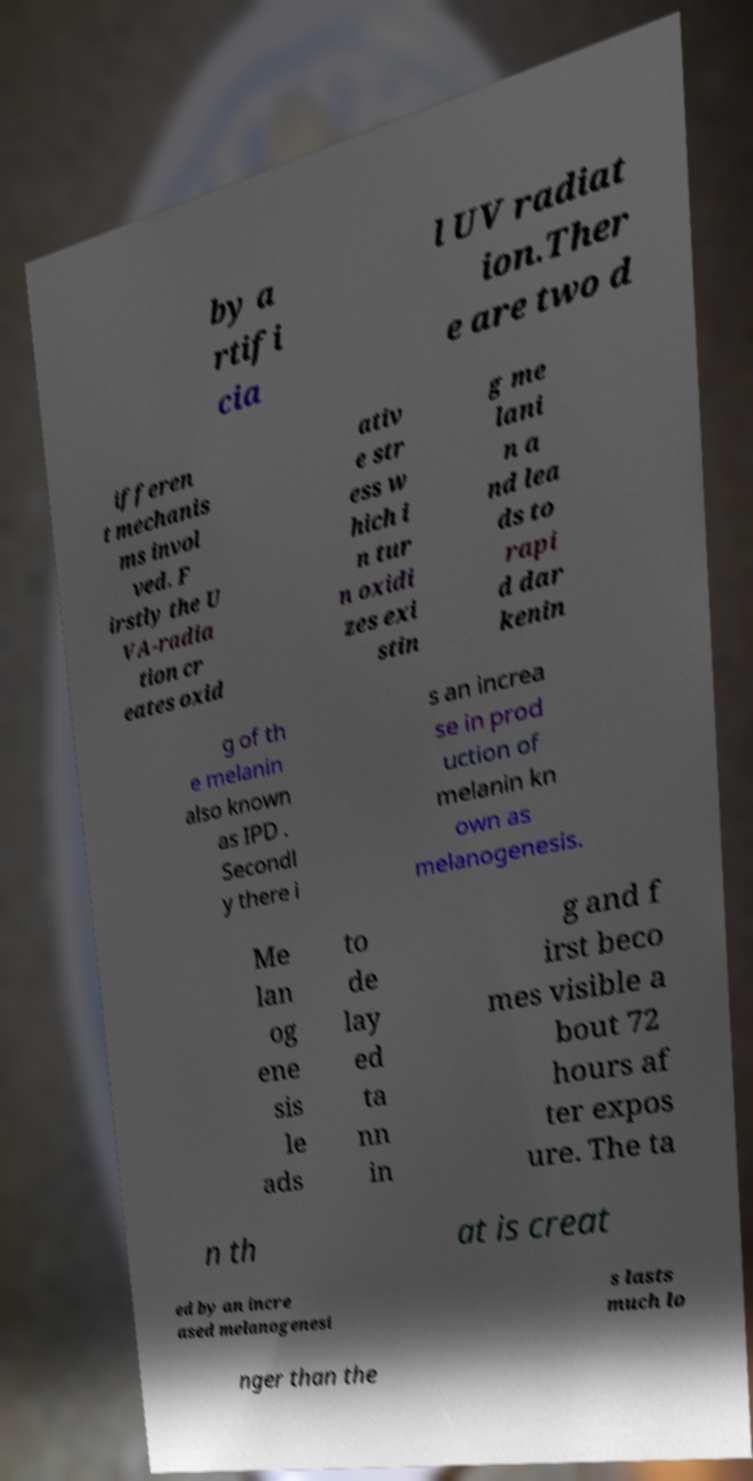Can you accurately transcribe the text from the provided image for me? by a rtifi cia l UV radiat ion.Ther e are two d ifferen t mechanis ms invol ved. F irstly the U VA-radia tion cr eates oxid ativ e str ess w hich i n tur n oxidi zes exi stin g me lani n a nd lea ds to rapi d dar kenin g of th e melanin also known as IPD . Secondl y there i s an increa se in prod uction of melanin kn own as melanogenesis. Me lan og ene sis le ads to de lay ed ta nn in g and f irst beco mes visible a bout 72 hours af ter expos ure. The ta n th at is creat ed by an incre ased melanogenesi s lasts much lo nger than the 